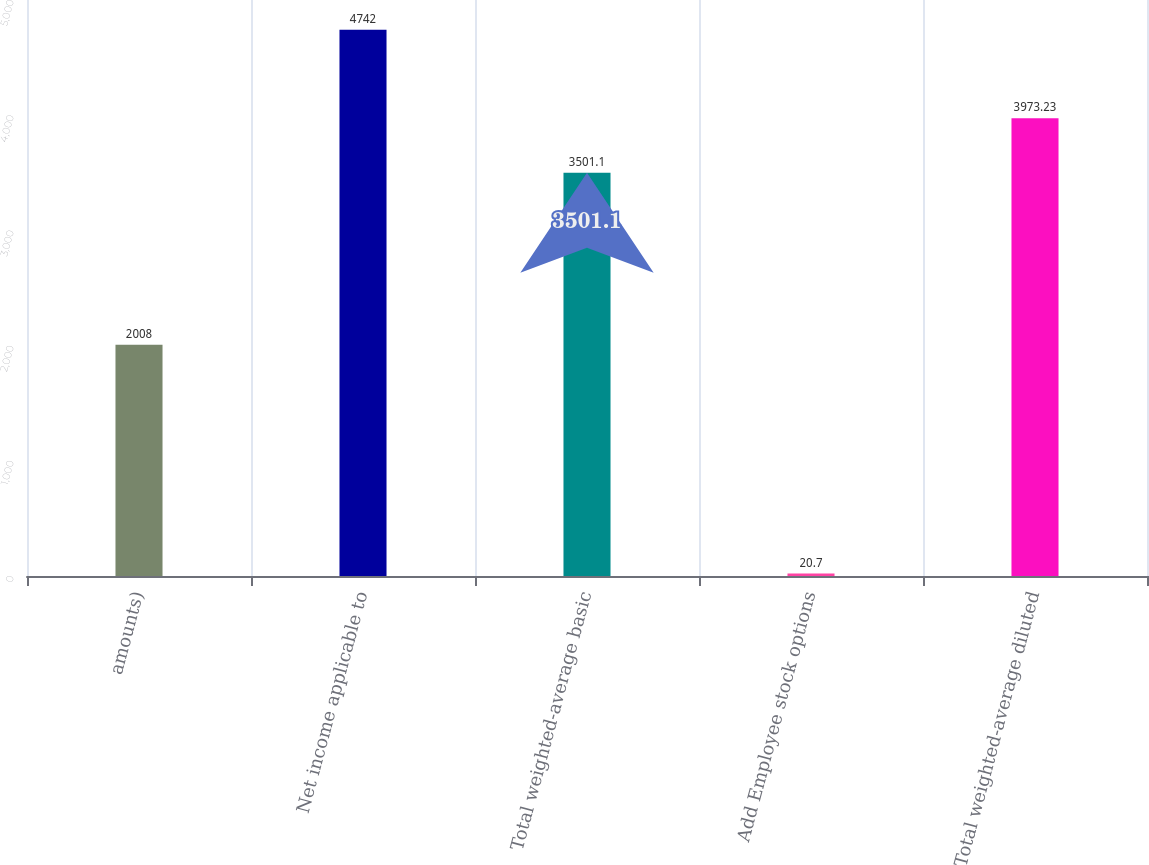Convert chart. <chart><loc_0><loc_0><loc_500><loc_500><bar_chart><fcel>amounts)<fcel>Net income applicable to<fcel>Total weighted-average basic<fcel>Add Employee stock options<fcel>Total weighted-average diluted<nl><fcel>2008<fcel>4742<fcel>3501.1<fcel>20.7<fcel>3973.23<nl></chart> 